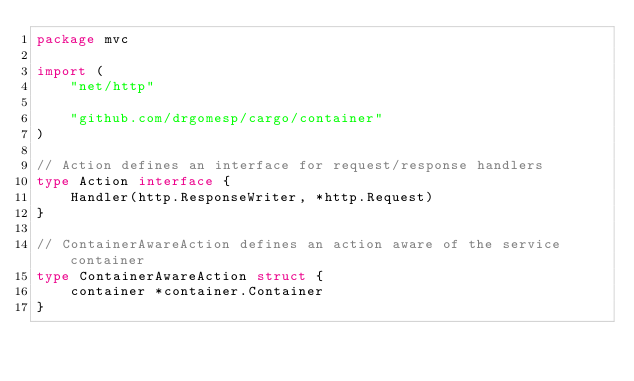<code> <loc_0><loc_0><loc_500><loc_500><_Go_>package mvc

import (
	"net/http"

	"github.com/drgomesp/cargo/container"
)

// Action defines an interface for request/response handlers
type Action interface {
	Handler(http.ResponseWriter, *http.Request)
}

// ContainerAwareAction defines an action aware of the service container
type ContainerAwareAction struct {
	container *container.Container
}
</code> 